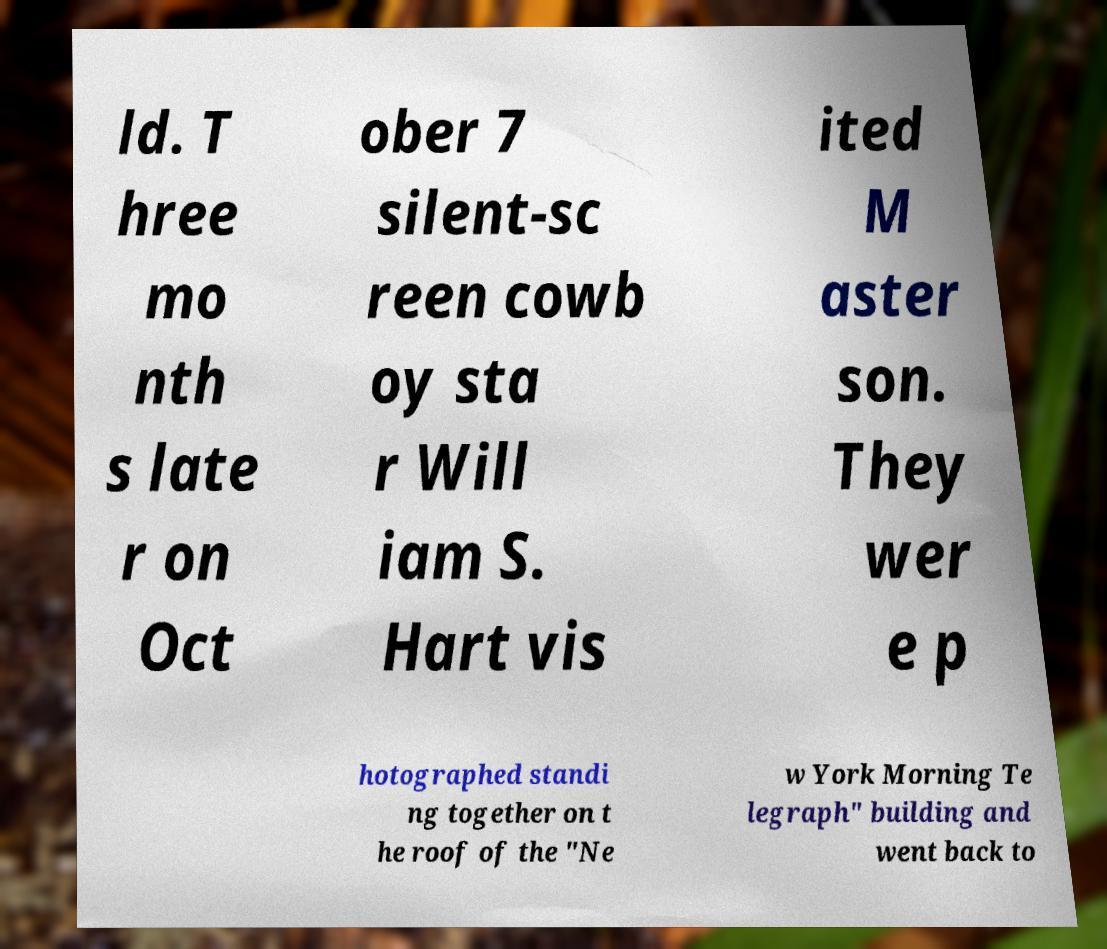For documentation purposes, I need the text within this image transcribed. Could you provide that? ld. T hree mo nth s late r on Oct ober 7 silent-sc reen cowb oy sta r Will iam S. Hart vis ited M aster son. They wer e p hotographed standi ng together on t he roof of the "Ne w York Morning Te legraph" building and went back to 